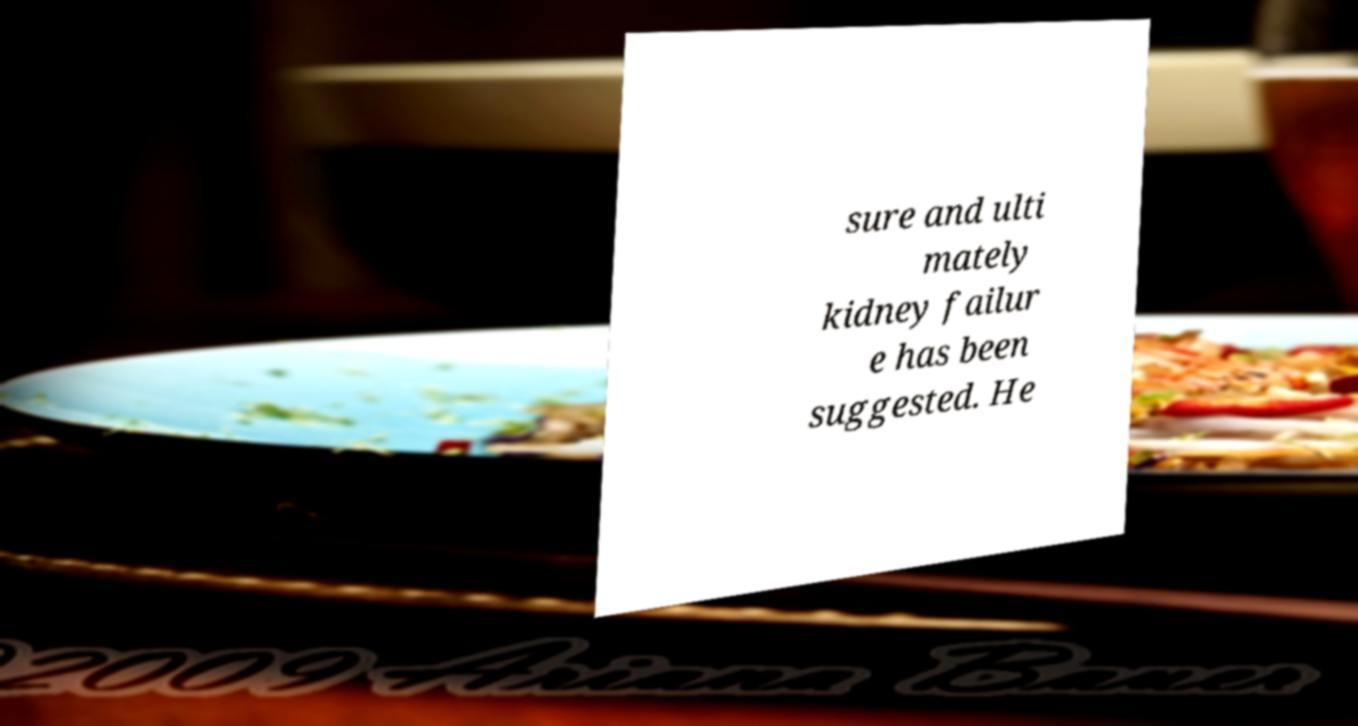Could you assist in decoding the text presented in this image and type it out clearly? sure and ulti mately kidney failur e has been suggested. He 